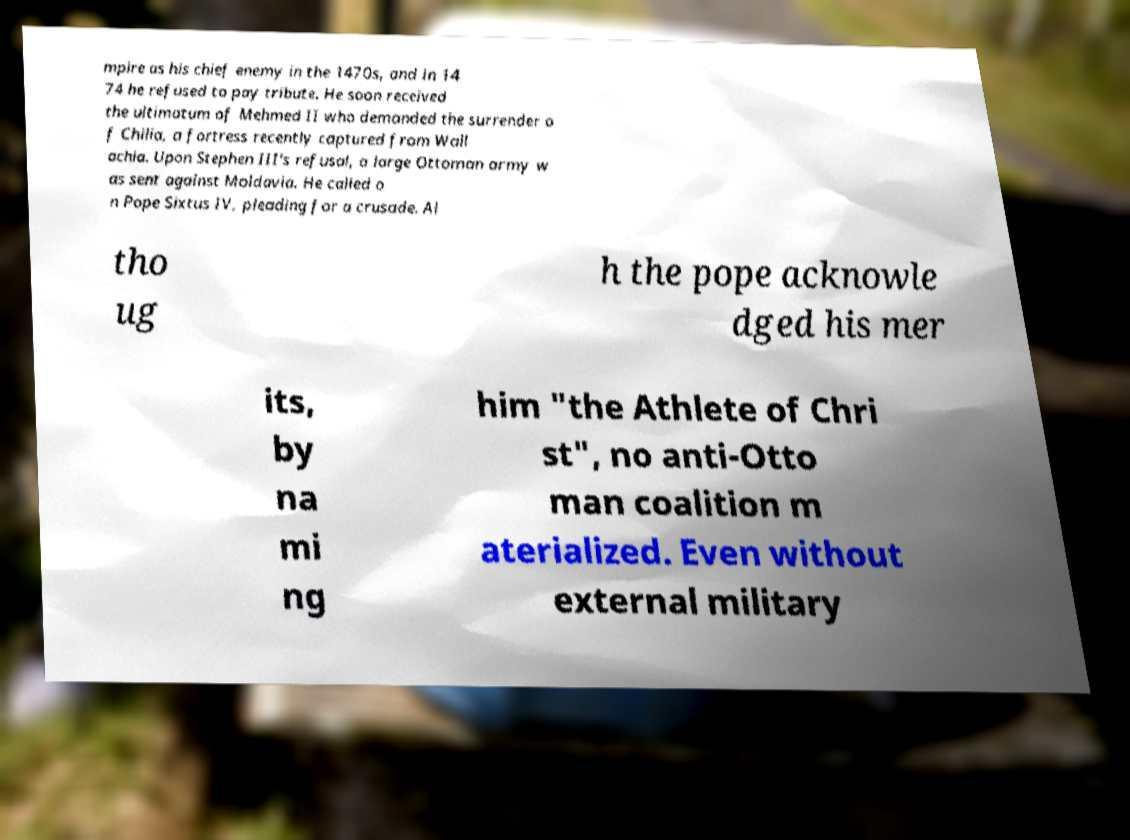There's text embedded in this image that I need extracted. Can you transcribe it verbatim? mpire as his chief enemy in the 1470s, and in 14 74 he refused to pay tribute. He soon received the ultimatum of Mehmed II who demanded the surrender o f Chilia, a fortress recently captured from Wall achia. Upon Stephen III's refusal, a large Ottoman army w as sent against Moldavia. He called o n Pope Sixtus IV, pleading for a crusade. Al tho ug h the pope acknowle dged his mer its, by na mi ng him "the Athlete of Chri st", no anti-Otto man coalition m aterialized. Even without external military 